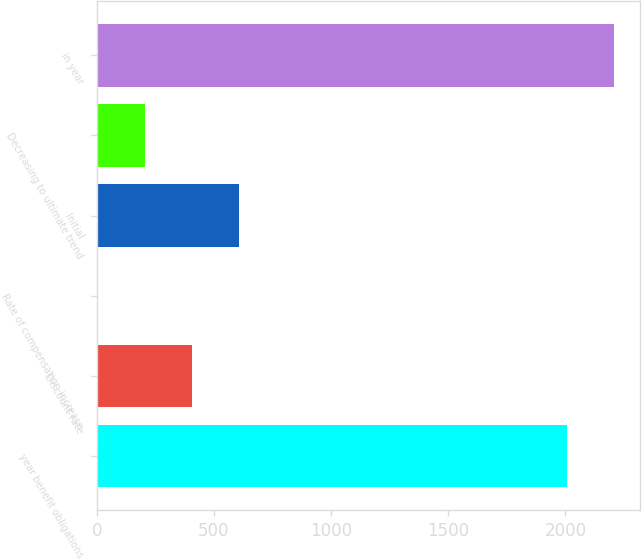<chart> <loc_0><loc_0><loc_500><loc_500><bar_chart><fcel>year benefit obligations<fcel>Discount rate<fcel>Rate of compensation increase<fcel>Initial<fcel>Decreasing to ultimate trend<fcel>in year<nl><fcel>2007<fcel>405.41<fcel>3.75<fcel>606.24<fcel>204.58<fcel>2207.82<nl></chart> 